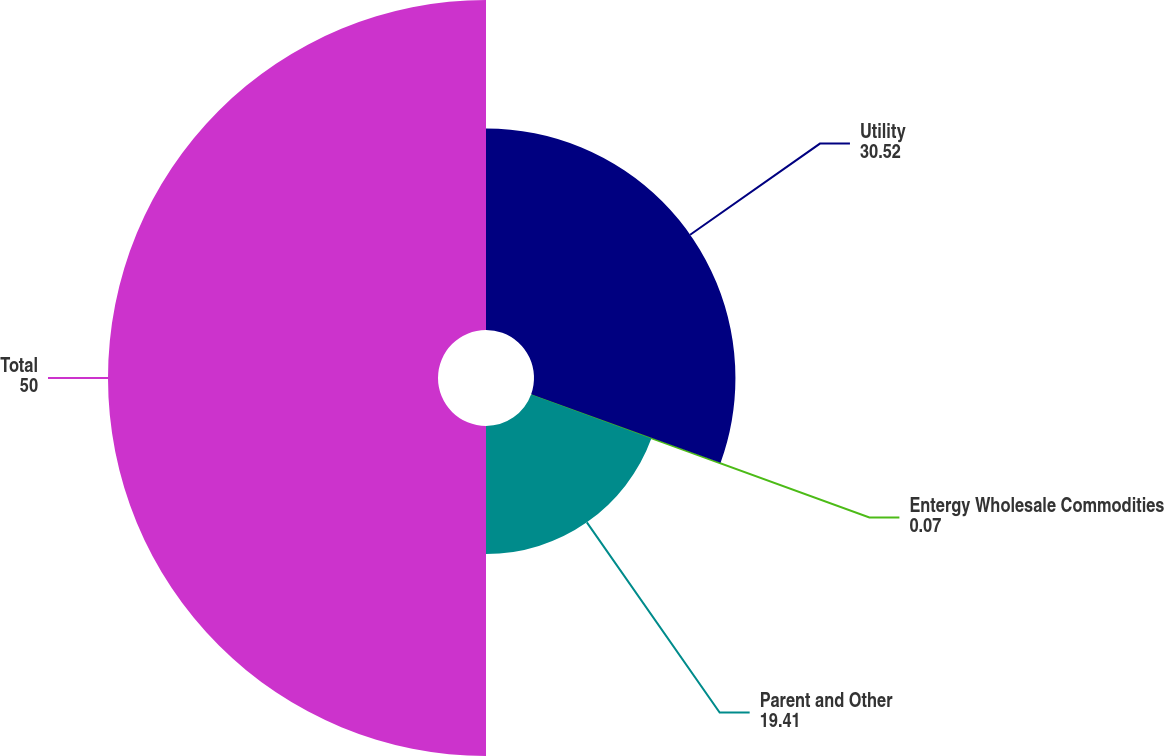Convert chart to OTSL. <chart><loc_0><loc_0><loc_500><loc_500><pie_chart><fcel>Utility<fcel>Entergy Wholesale Commodities<fcel>Parent and Other<fcel>Total<nl><fcel>30.52%<fcel>0.07%<fcel>19.41%<fcel>50.0%<nl></chart> 